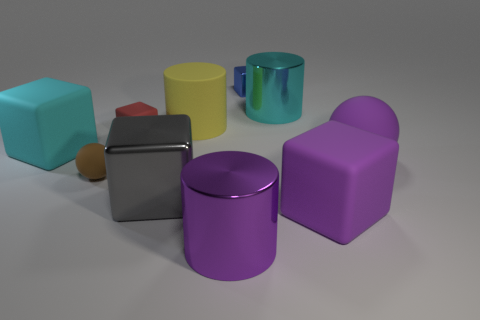Subtract all small blocks. How many blocks are left? 3 Subtract all small red rubber blocks. Subtract all purple matte spheres. How many objects are left? 8 Add 4 big purple balls. How many big purple balls are left? 5 Add 7 small yellow matte cylinders. How many small yellow matte cylinders exist? 7 Subtract all blue blocks. How many blocks are left? 4 Subtract 1 purple cylinders. How many objects are left? 9 Subtract all spheres. How many objects are left? 8 Subtract 1 balls. How many balls are left? 1 Subtract all blue cylinders. Subtract all brown cubes. How many cylinders are left? 3 Subtract all blue cylinders. How many green cubes are left? 0 